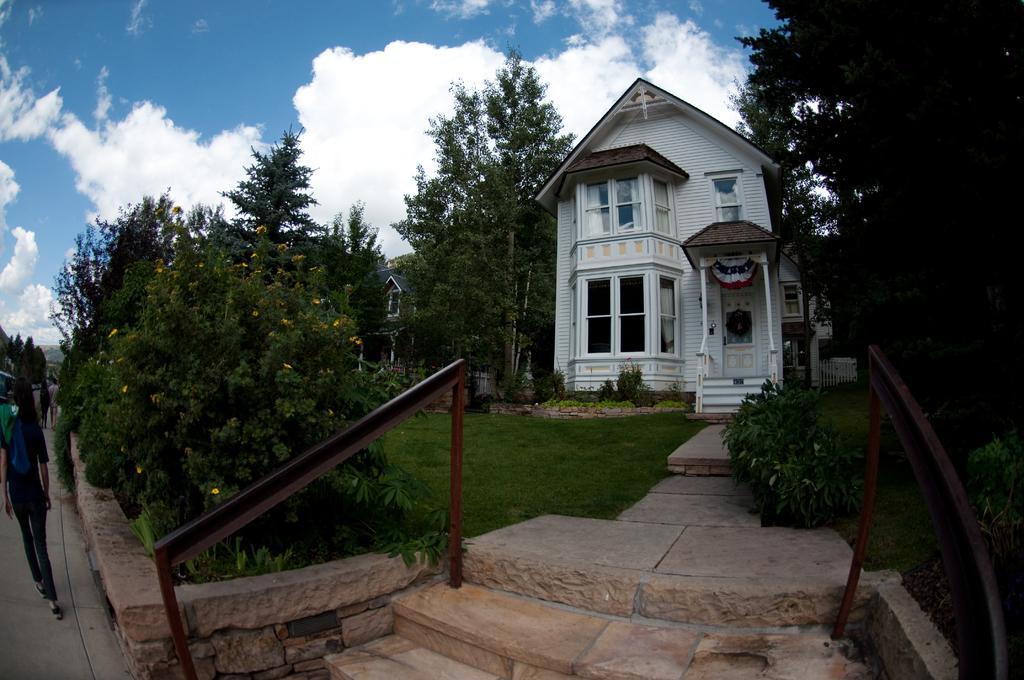In one or two sentences, can you explain what this image depicts? In this picture we can see grass, plants, trees, buildings, and few people. In the background there is sky with clouds. 